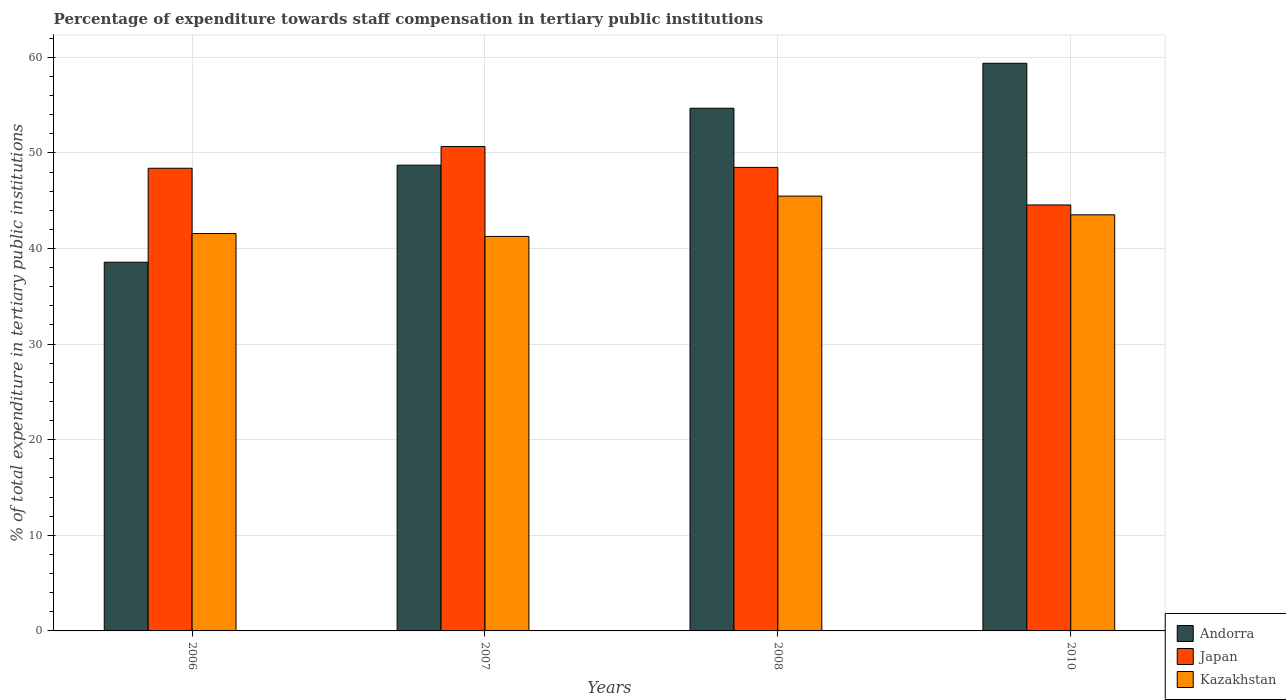How many different coloured bars are there?
Keep it short and to the point. 3. How many groups of bars are there?
Give a very brief answer. 4. Are the number of bars per tick equal to the number of legend labels?
Your answer should be very brief. Yes. Are the number of bars on each tick of the X-axis equal?
Your answer should be very brief. Yes. How many bars are there on the 2nd tick from the left?
Your answer should be very brief. 3. In how many cases, is the number of bars for a given year not equal to the number of legend labels?
Make the answer very short. 0. What is the percentage of expenditure towards staff compensation in Kazakhstan in 2006?
Offer a terse response. 41.57. Across all years, what is the maximum percentage of expenditure towards staff compensation in Japan?
Provide a succinct answer. 50.67. Across all years, what is the minimum percentage of expenditure towards staff compensation in Andorra?
Your response must be concise. 38.57. What is the total percentage of expenditure towards staff compensation in Japan in the graph?
Offer a very short reply. 192.11. What is the difference between the percentage of expenditure towards staff compensation in Kazakhstan in 2006 and that in 2007?
Your response must be concise. 0.3. What is the difference between the percentage of expenditure towards staff compensation in Japan in 2008 and the percentage of expenditure towards staff compensation in Andorra in 2007?
Give a very brief answer. -0.23. What is the average percentage of expenditure towards staff compensation in Japan per year?
Offer a very short reply. 48.03. In the year 2010, what is the difference between the percentage of expenditure towards staff compensation in Andorra and percentage of expenditure towards staff compensation in Kazakhstan?
Your answer should be very brief. 15.85. What is the ratio of the percentage of expenditure towards staff compensation in Kazakhstan in 2008 to that in 2010?
Make the answer very short. 1.04. Is the difference between the percentage of expenditure towards staff compensation in Andorra in 2006 and 2008 greater than the difference between the percentage of expenditure towards staff compensation in Kazakhstan in 2006 and 2008?
Your answer should be compact. No. What is the difference between the highest and the second highest percentage of expenditure towards staff compensation in Kazakhstan?
Provide a short and direct response. 1.96. What is the difference between the highest and the lowest percentage of expenditure towards staff compensation in Kazakhstan?
Give a very brief answer. 4.22. What does the 2nd bar from the left in 2007 represents?
Make the answer very short. Japan. What does the 1st bar from the right in 2008 represents?
Your answer should be compact. Kazakhstan. Is it the case that in every year, the sum of the percentage of expenditure towards staff compensation in Andorra and percentage of expenditure towards staff compensation in Kazakhstan is greater than the percentage of expenditure towards staff compensation in Japan?
Keep it short and to the point. Yes. How many bars are there?
Your response must be concise. 12. How many years are there in the graph?
Give a very brief answer. 4. What is the difference between two consecutive major ticks on the Y-axis?
Your response must be concise. 10. Are the values on the major ticks of Y-axis written in scientific E-notation?
Provide a short and direct response. No. Does the graph contain any zero values?
Give a very brief answer. No. How many legend labels are there?
Keep it short and to the point. 3. What is the title of the graph?
Make the answer very short. Percentage of expenditure towards staff compensation in tertiary public institutions. Does "Guinea" appear as one of the legend labels in the graph?
Your response must be concise. No. What is the label or title of the Y-axis?
Your response must be concise. % of total expenditure in tertiary public institutions. What is the % of total expenditure in tertiary public institutions in Andorra in 2006?
Your response must be concise. 38.57. What is the % of total expenditure in tertiary public institutions in Japan in 2006?
Provide a succinct answer. 48.4. What is the % of total expenditure in tertiary public institutions of Kazakhstan in 2006?
Ensure brevity in your answer.  41.57. What is the % of total expenditure in tertiary public institutions of Andorra in 2007?
Give a very brief answer. 48.72. What is the % of total expenditure in tertiary public institutions of Japan in 2007?
Offer a terse response. 50.67. What is the % of total expenditure in tertiary public institutions in Kazakhstan in 2007?
Give a very brief answer. 41.27. What is the % of total expenditure in tertiary public institutions of Andorra in 2008?
Your answer should be compact. 54.67. What is the % of total expenditure in tertiary public institutions in Japan in 2008?
Give a very brief answer. 48.49. What is the % of total expenditure in tertiary public institutions of Kazakhstan in 2008?
Give a very brief answer. 45.48. What is the % of total expenditure in tertiary public institutions of Andorra in 2010?
Provide a short and direct response. 59.38. What is the % of total expenditure in tertiary public institutions of Japan in 2010?
Offer a very short reply. 44.56. What is the % of total expenditure in tertiary public institutions in Kazakhstan in 2010?
Keep it short and to the point. 43.52. Across all years, what is the maximum % of total expenditure in tertiary public institutions in Andorra?
Give a very brief answer. 59.38. Across all years, what is the maximum % of total expenditure in tertiary public institutions of Japan?
Offer a terse response. 50.67. Across all years, what is the maximum % of total expenditure in tertiary public institutions in Kazakhstan?
Provide a short and direct response. 45.48. Across all years, what is the minimum % of total expenditure in tertiary public institutions of Andorra?
Keep it short and to the point. 38.57. Across all years, what is the minimum % of total expenditure in tertiary public institutions of Japan?
Make the answer very short. 44.56. Across all years, what is the minimum % of total expenditure in tertiary public institutions of Kazakhstan?
Offer a very short reply. 41.27. What is the total % of total expenditure in tertiary public institutions in Andorra in the graph?
Make the answer very short. 201.34. What is the total % of total expenditure in tertiary public institutions of Japan in the graph?
Make the answer very short. 192.11. What is the total % of total expenditure in tertiary public institutions in Kazakhstan in the graph?
Make the answer very short. 171.84. What is the difference between the % of total expenditure in tertiary public institutions in Andorra in 2006 and that in 2007?
Make the answer very short. -10.15. What is the difference between the % of total expenditure in tertiary public institutions of Japan in 2006 and that in 2007?
Ensure brevity in your answer.  -2.27. What is the difference between the % of total expenditure in tertiary public institutions in Kazakhstan in 2006 and that in 2007?
Provide a succinct answer. 0.3. What is the difference between the % of total expenditure in tertiary public institutions in Andorra in 2006 and that in 2008?
Provide a succinct answer. -16.1. What is the difference between the % of total expenditure in tertiary public institutions of Japan in 2006 and that in 2008?
Give a very brief answer. -0.09. What is the difference between the % of total expenditure in tertiary public institutions of Kazakhstan in 2006 and that in 2008?
Keep it short and to the point. -3.92. What is the difference between the % of total expenditure in tertiary public institutions of Andorra in 2006 and that in 2010?
Your answer should be very brief. -20.81. What is the difference between the % of total expenditure in tertiary public institutions in Japan in 2006 and that in 2010?
Provide a short and direct response. 3.84. What is the difference between the % of total expenditure in tertiary public institutions of Kazakhstan in 2006 and that in 2010?
Your answer should be compact. -1.96. What is the difference between the % of total expenditure in tertiary public institutions in Andorra in 2007 and that in 2008?
Keep it short and to the point. -5.95. What is the difference between the % of total expenditure in tertiary public institutions of Japan in 2007 and that in 2008?
Provide a succinct answer. 2.18. What is the difference between the % of total expenditure in tertiary public institutions in Kazakhstan in 2007 and that in 2008?
Make the answer very short. -4.22. What is the difference between the % of total expenditure in tertiary public institutions of Andorra in 2007 and that in 2010?
Keep it short and to the point. -10.66. What is the difference between the % of total expenditure in tertiary public institutions in Japan in 2007 and that in 2010?
Your answer should be compact. 6.11. What is the difference between the % of total expenditure in tertiary public institutions in Kazakhstan in 2007 and that in 2010?
Keep it short and to the point. -2.26. What is the difference between the % of total expenditure in tertiary public institutions of Andorra in 2008 and that in 2010?
Provide a succinct answer. -4.71. What is the difference between the % of total expenditure in tertiary public institutions in Japan in 2008 and that in 2010?
Keep it short and to the point. 3.93. What is the difference between the % of total expenditure in tertiary public institutions of Kazakhstan in 2008 and that in 2010?
Your answer should be compact. 1.96. What is the difference between the % of total expenditure in tertiary public institutions of Andorra in 2006 and the % of total expenditure in tertiary public institutions of Japan in 2007?
Your response must be concise. -12.1. What is the difference between the % of total expenditure in tertiary public institutions in Andorra in 2006 and the % of total expenditure in tertiary public institutions in Kazakhstan in 2007?
Your answer should be compact. -2.7. What is the difference between the % of total expenditure in tertiary public institutions of Japan in 2006 and the % of total expenditure in tertiary public institutions of Kazakhstan in 2007?
Give a very brief answer. 7.13. What is the difference between the % of total expenditure in tertiary public institutions in Andorra in 2006 and the % of total expenditure in tertiary public institutions in Japan in 2008?
Your response must be concise. -9.92. What is the difference between the % of total expenditure in tertiary public institutions in Andorra in 2006 and the % of total expenditure in tertiary public institutions in Kazakhstan in 2008?
Your answer should be very brief. -6.92. What is the difference between the % of total expenditure in tertiary public institutions of Japan in 2006 and the % of total expenditure in tertiary public institutions of Kazakhstan in 2008?
Your response must be concise. 2.91. What is the difference between the % of total expenditure in tertiary public institutions in Andorra in 2006 and the % of total expenditure in tertiary public institutions in Japan in 2010?
Give a very brief answer. -5.99. What is the difference between the % of total expenditure in tertiary public institutions of Andorra in 2006 and the % of total expenditure in tertiary public institutions of Kazakhstan in 2010?
Your answer should be compact. -4.96. What is the difference between the % of total expenditure in tertiary public institutions of Japan in 2006 and the % of total expenditure in tertiary public institutions of Kazakhstan in 2010?
Give a very brief answer. 4.87. What is the difference between the % of total expenditure in tertiary public institutions of Andorra in 2007 and the % of total expenditure in tertiary public institutions of Japan in 2008?
Ensure brevity in your answer.  0.23. What is the difference between the % of total expenditure in tertiary public institutions in Andorra in 2007 and the % of total expenditure in tertiary public institutions in Kazakhstan in 2008?
Your response must be concise. 3.24. What is the difference between the % of total expenditure in tertiary public institutions of Japan in 2007 and the % of total expenditure in tertiary public institutions of Kazakhstan in 2008?
Ensure brevity in your answer.  5.18. What is the difference between the % of total expenditure in tertiary public institutions of Andorra in 2007 and the % of total expenditure in tertiary public institutions of Japan in 2010?
Your answer should be very brief. 4.16. What is the difference between the % of total expenditure in tertiary public institutions in Andorra in 2007 and the % of total expenditure in tertiary public institutions in Kazakhstan in 2010?
Your response must be concise. 5.2. What is the difference between the % of total expenditure in tertiary public institutions of Japan in 2007 and the % of total expenditure in tertiary public institutions of Kazakhstan in 2010?
Offer a very short reply. 7.14. What is the difference between the % of total expenditure in tertiary public institutions in Andorra in 2008 and the % of total expenditure in tertiary public institutions in Japan in 2010?
Offer a terse response. 10.11. What is the difference between the % of total expenditure in tertiary public institutions of Andorra in 2008 and the % of total expenditure in tertiary public institutions of Kazakhstan in 2010?
Offer a very short reply. 11.15. What is the difference between the % of total expenditure in tertiary public institutions of Japan in 2008 and the % of total expenditure in tertiary public institutions of Kazakhstan in 2010?
Make the answer very short. 4.96. What is the average % of total expenditure in tertiary public institutions of Andorra per year?
Ensure brevity in your answer.  50.33. What is the average % of total expenditure in tertiary public institutions in Japan per year?
Give a very brief answer. 48.03. What is the average % of total expenditure in tertiary public institutions in Kazakhstan per year?
Your answer should be compact. 42.96. In the year 2006, what is the difference between the % of total expenditure in tertiary public institutions of Andorra and % of total expenditure in tertiary public institutions of Japan?
Ensure brevity in your answer.  -9.83. In the year 2006, what is the difference between the % of total expenditure in tertiary public institutions of Andorra and % of total expenditure in tertiary public institutions of Kazakhstan?
Offer a terse response. -3. In the year 2006, what is the difference between the % of total expenditure in tertiary public institutions in Japan and % of total expenditure in tertiary public institutions in Kazakhstan?
Ensure brevity in your answer.  6.83. In the year 2007, what is the difference between the % of total expenditure in tertiary public institutions in Andorra and % of total expenditure in tertiary public institutions in Japan?
Your answer should be compact. -1.95. In the year 2007, what is the difference between the % of total expenditure in tertiary public institutions of Andorra and % of total expenditure in tertiary public institutions of Kazakhstan?
Give a very brief answer. 7.45. In the year 2007, what is the difference between the % of total expenditure in tertiary public institutions in Japan and % of total expenditure in tertiary public institutions in Kazakhstan?
Offer a very short reply. 9.4. In the year 2008, what is the difference between the % of total expenditure in tertiary public institutions of Andorra and % of total expenditure in tertiary public institutions of Japan?
Offer a terse response. 6.18. In the year 2008, what is the difference between the % of total expenditure in tertiary public institutions in Andorra and % of total expenditure in tertiary public institutions in Kazakhstan?
Your answer should be very brief. 9.19. In the year 2008, what is the difference between the % of total expenditure in tertiary public institutions in Japan and % of total expenditure in tertiary public institutions in Kazakhstan?
Your answer should be compact. 3. In the year 2010, what is the difference between the % of total expenditure in tertiary public institutions of Andorra and % of total expenditure in tertiary public institutions of Japan?
Your response must be concise. 14.82. In the year 2010, what is the difference between the % of total expenditure in tertiary public institutions of Andorra and % of total expenditure in tertiary public institutions of Kazakhstan?
Your answer should be compact. 15.85. In the year 2010, what is the difference between the % of total expenditure in tertiary public institutions of Japan and % of total expenditure in tertiary public institutions of Kazakhstan?
Provide a short and direct response. 1.03. What is the ratio of the % of total expenditure in tertiary public institutions of Andorra in 2006 to that in 2007?
Ensure brevity in your answer.  0.79. What is the ratio of the % of total expenditure in tertiary public institutions of Japan in 2006 to that in 2007?
Your answer should be compact. 0.96. What is the ratio of the % of total expenditure in tertiary public institutions of Kazakhstan in 2006 to that in 2007?
Offer a terse response. 1.01. What is the ratio of the % of total expenditure in tertiary public institutions in Andorra in 2006 to that in 2008?
Make the answer very short. 0.71. What is the ratio of the % of total expenditure in tertiary public institutions of Kazakhstan in 2006 to that in 2008?
Provide a short and direct response. 0.91. What is the ratio of the % of total expenditure in tertiary public institutions of Andorra in 2006 to that in 2010?
Provide a short and direct response. 0.65. What is the ratio of the % of total expenditure in tertiary public institutions in Japan in 2006 to that in 2010?
Your response must be concise. 1.09. What is the ratio of the % of total expenditure in tertiary public institutions in Kazakhstan in 2006 to that in 2010?
Provide a short and direct response. 0.95. What is the ratio of the % of total expenditure in tertiary public institutions of Andorra in 2007 to that in 2008?
Keep it short and to the point. 0.89. What is the ratio of the % of total expenditure in tertiary public institutions in Japan in 2007 to that in 2008?
Make the answer very short. 1.04. What is the ratio of the % of total expenditure in tertiary public institutions of Kazakhstan in 2007 to that in 2008?
Your answer should be compact. 0.91. What is the ratio of the % of total expenditure in tertiary public institutions in Andorra in 2007 to that in 2010?
Keep it short and to the point. 0.82. What is the ratio of the % of total expenditure in tertiary public institutions in Japan in 2007 to that in 2010?
Keep it short and to the point. 1.14. What is the ratio of the % of total expenditure in tertiary public institutions of Kazakhstan in 2007 to that in 2010?
Your answer should be compact. 0.95. What is the ratio of the % of total expenditure in tertiary public institutions of Andorra in 2008 to that in 2010?
Keep it short and to the point. 0.92. What is the ratio of the % of total expenditure in tertiary public institutions of Japan in 2008 to that in 2010?
Make the answer very short. 1.09. What is the ratio of the % of total expenditure in tertiary public institutions of Kazakhstan in 2008 to that in 2010?
Offer a terse response. 1.04. What is the difference between the highest and the second highest % of total expenditure in tertiary public institutions in Andorra?
Provide a short and direct response. 4.71. What is the difference between the highest and the second highest % of total expenditure in tertiary public institutions in Japan?
Your answer should be compact. 2.18. What is the difference between the highest and the second highest % of total expenditure in tertiary public institutions in Kazakhstan?
Give a very brief answer. 1.96. What is the difference between the highest and the lowest % of total expenditure in tertiary public institutions of Andorra?
Your answer should be compact. 20.81. What is the difference between the highest and the lowest % of total expenditure in tertiary public institutions of Japan?
Offer a very short reply. 6.11. What is the difference between the highest and the lowest % of total expenditure in tertiary public institutions of Kazakhstan?
Give a very brief answer. 4.22. 